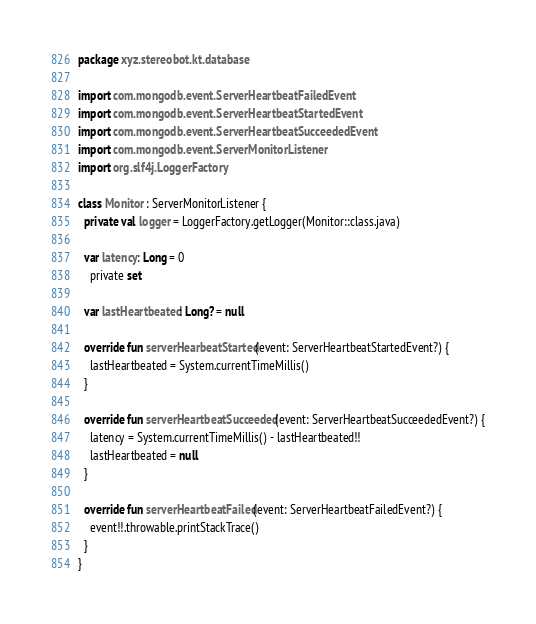Convert code to text. <code><loc_0><loc_0><loc_500><loc_500><_Kotlin_>package xyz.stereobot.kt.database

import com.mongodb.event.ServerHeartbeatFailedEvent
import com.mongodb.event.ServerHeartbeatStartedEvent
import com.mongodb.event.ServerHeartbeatSucceededEvent
import com.mongodb.event.ServerMonitorListener
import org.slf4j.LoggerFactory

class Monitor : ServerMonitorListener {
  private val logger = LoggerFactory.getLogger(Monitor::class.java)
  
  var latency: Long = 0
    private set
  
  var lastHeartbeated: Long? = null
  
  override fun serverHearbeatStarted(event: ServerHeartbeatStartedEvent?) {
    lastHeartbeated = System.currentTimeMillis()
  }
  
  override fun serverHeartbeatSucceeded(event: ServerHeartbeatSucceededEvent?) {
    latency = System.currentTimeMillis() - lastHeartbeated!!
    lastHeartbeated = null
  }
  
  override fun serverHeartbeatFailed(event: ServerHeartbeatFailedEvent?) {
    event!!.throwable.printStackTrace()
  }
}</code> 